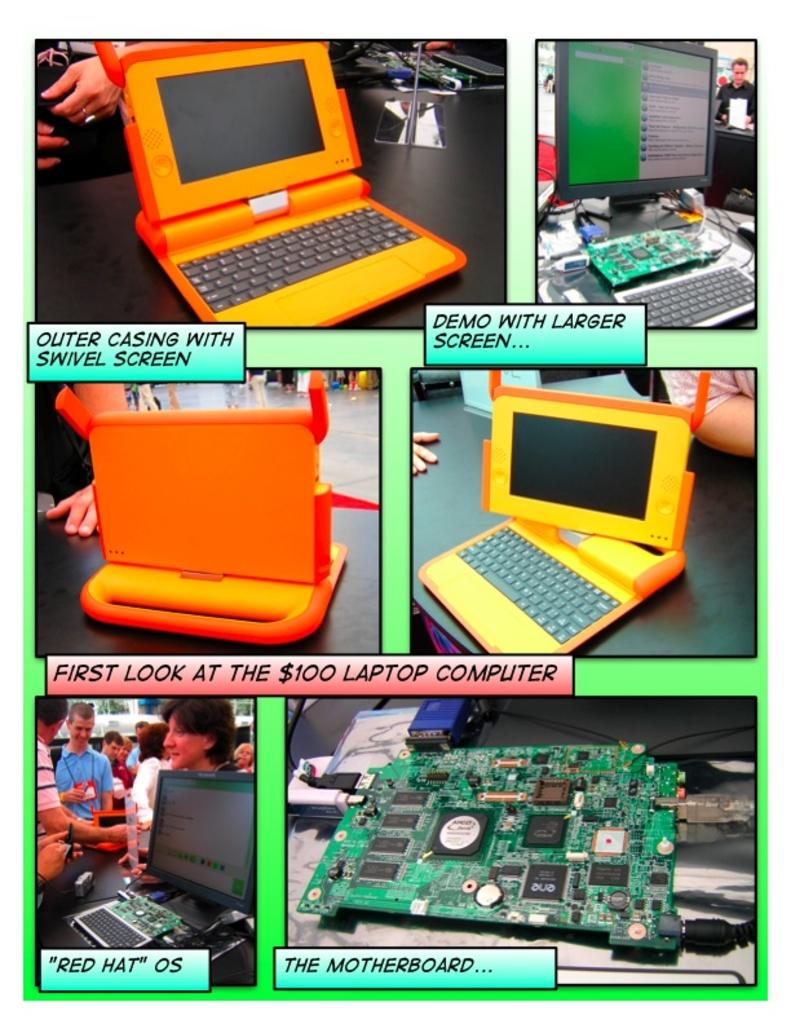<image>
Offer a succinct explanation of the picture presented. A display of laptops and computers with a sign that says "First look at the $100 laptop computer" 